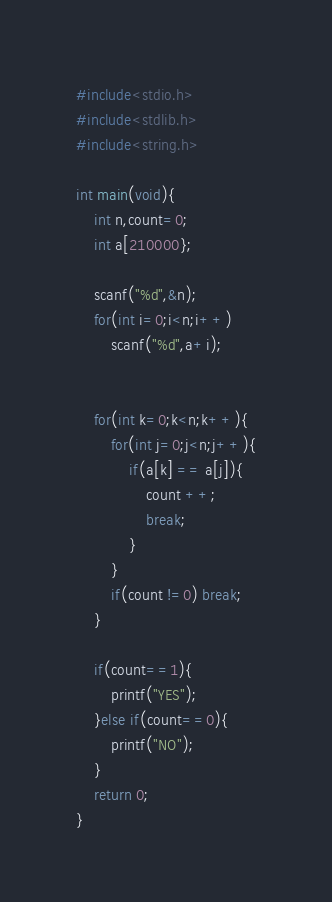Convert code to text. <code><loc_0><loc_0><loc_500><loc_500><_C_>#include<stdio.h>
#include<stdlib.h>
#include<string.h>

int main(void){
    int n,count=0;
    int a[210000};

    scanf("%d",&n);
    for(int i=0;i<n;i++)
        scanf("%d",a+i);


    for(int k=0;k<n;k++){
        for(int j=0;j<n;j++){
            if(a[k] == a[j]){
                count ++;
                break;
            }
        }
        if(count !=0) break;
    }

    if(count==1){
        printf("YES");
    }else if(count==0){
        printf("NO");
    }
    return 0;
}</code> 